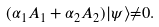<formula> <loc_0><loc_0><loc_500><loc_500>( { \alpha } _ { 1 } A _ { 1 } + { \alpha } _ { 2 } A _ { 2 } ) | { \psi } { \rangle } { \neq } 0 .</formula> 